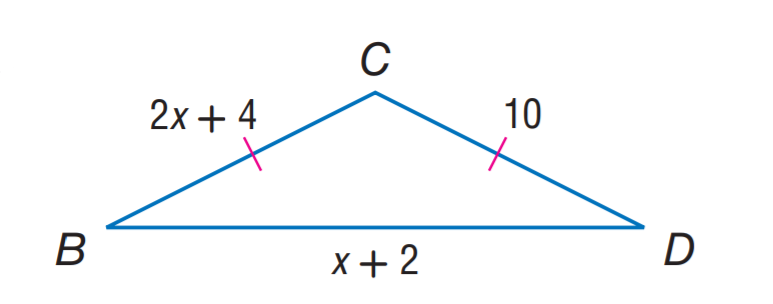Answer the mathemtical geometry problem and directly provide the correct option letter.
Question: Find B D.
Choices: A: 3 B: 4 C: 5 D: 6 C 